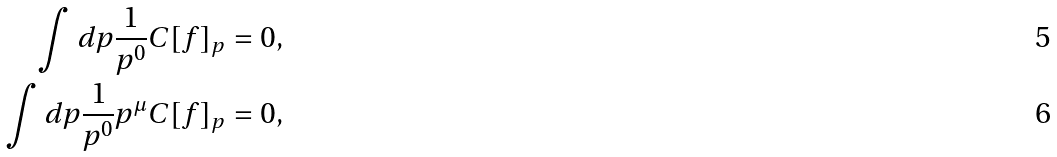Convert formula to latex. <formula><loc_0><loc_0><loc_500><loc_500>\int d p \frac { 1 } { p ^ { 0 } } C [ f ] _ { p } & = 0 , \\ \int d p \frac { 1 } { p ^ { 0 } } p ^ { \mu } C [ f ] _ { p } & = 0 ,</formula> 